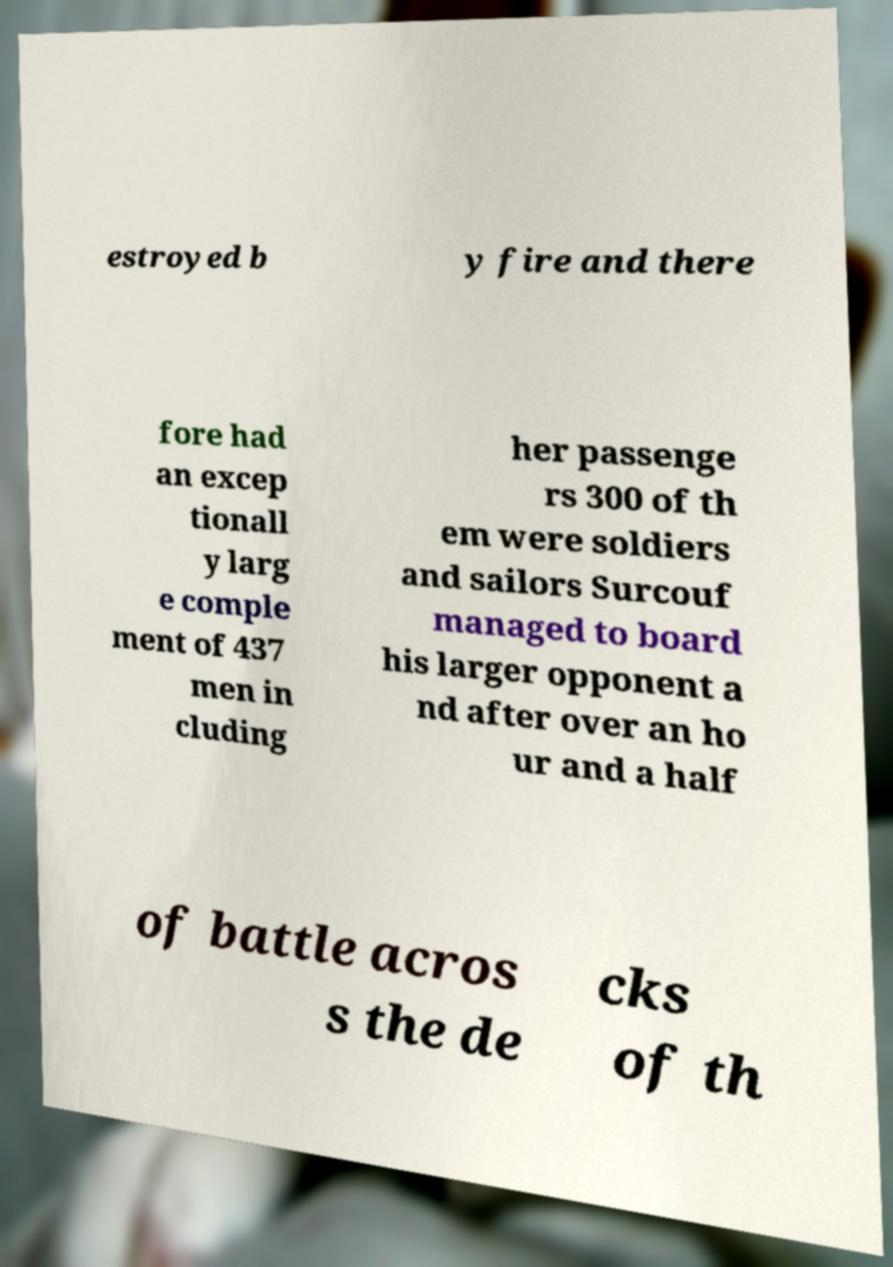What messages or text are displayed in this image? I need them in a readable, typed format. estroyed b y fire and there fore had an excep tionall y larg e comple ment of 437 men in cluding her passenge rs 300 of th em were soldiers and sailors Surcouf managed to board his larger opponent a nd after over an ho ur and a half of battle acros s the de cks of th 